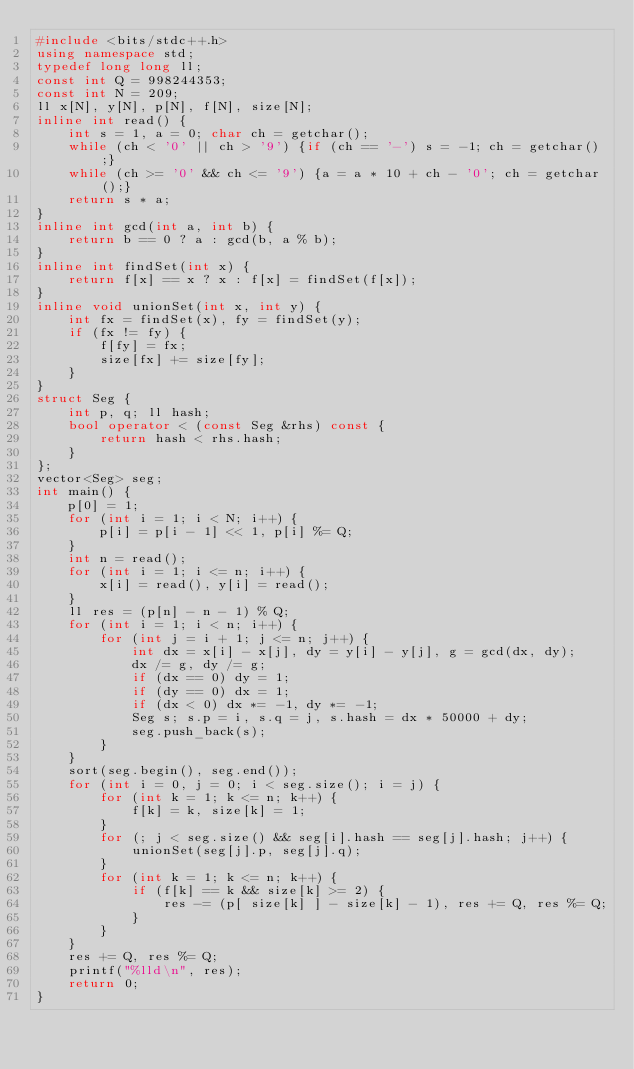<code> <loc_0><loc_0><loc_500><loc_500><_C++_>#include <bits/stdc++.h>
using namespace std;
typedef long long ll;
const int Q = 998244353;
const int N = 209;
ll x[N], y[N], p[N], f[N], size[N];
inline int read() {
    int s = 1, a = 0; char ch = getchar();
    while (ch < '0' || ch > '9') {if (ch == '-') s = -1; ch = getchar();}
    while (ch >= '0' && ch <= '9') {a = a * 10 + ch - '0'; ch = getchar();}
    return s * a;
}
inline int gcd(int a, int b) {
    return b == 0 ? a : gcd(b, a % b);
}
inline int findSet(int x) {
    return f[x] == x ? x : f[x] = findSet(f[x]);
}
inline void unionSet(int x, int y) {
    int fx = findSet(x), fy = findSet(y);
    if (fx != fy) {
        f[fy] = fx;
        size[fx] += size[fy];
    }
}
struct Seg {
    int p, q; ll hash;
    bool operator < (const Seg &rhs) const {
        return hash < rhs.hash;
    }
};
vector<Seg> seg;
int main() {
    p[0] = 1;
    for (int i = 1; i < N; i++) {
        p[i] = p[i - 1] << 1, p[i] %= Q;
    }
    int n = read();
    for (int i = 1; i <= n; i++) {
        x[i] = read(), y[i] = read();
    }
    ll res = (p[n] - n - 1) % Q;
    for (int i = 1; i < n; i++) {
        for (int j = i + 1; j <= n; j++) {
            int dx = x[i] - x[j], dy = y[i] - y[j], g = gcd(dx, dy);
            dx /= g, dy /= g;
            if (dx == 0) dy = 1;
            if (dy == 0) dx = 1;
            if (dx < 0) dx *= -1, dy *= -1;
            Seg s; s.p = i, s.q = j, s.hash = dx * 50000 + dy;
            seg.push_back(s);
        }
    }
    sort(seg.begin(), seg.end());
    for (int i = 0, j = 0; i < seg.size(); i = j) {
        for (int k = 1; k <= n; k++) {
            f[k] = k, size[k] = 1;
        }
        for (; j < seg.size() && seg[i].hash == seg[j].hash; j++) {
            unionSet(seg[j].p, seg[j].q);
        }
        for (int k = 1; k <= n; k++) {
            if (f[k] == k && size[k] >= 2) {
                res -= (p[ size[k] ] - size[k] - 1), res += Q, res %= Q;
            }
        }
    }
    res += Q, res %= Q;
    printf("%lld\n", res);
    return 0;
}</code> 